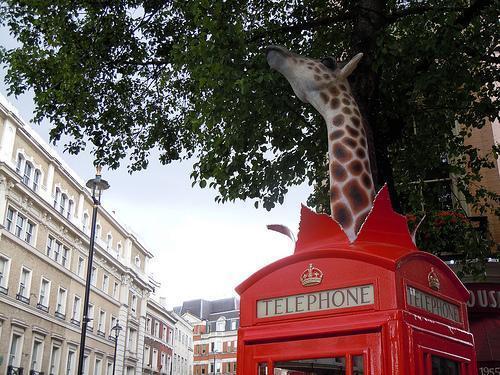How many giraffes are in this picture?
Give a very brief answer. 1. How many phone booths are there?
Give a very brief answer. 1. 